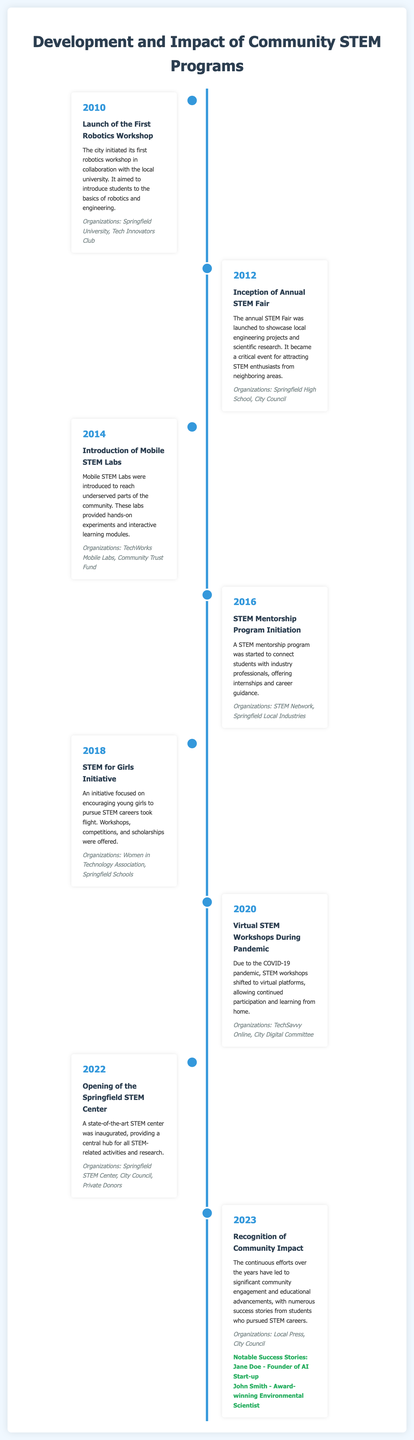what year was the First Robotics Workshop launched? The First Robotics Workshop was launched in 2010, as stated in the timeline.
Answer: 2010 what initiative was introduced in 2014? The initiative introduced in 2014 was Mobile STEM Labs, which aimed to reach underserved parts of the community.
Answer: Mobile STEM Labs which organizations were involved in the STEM for Girls Initiative? The organizations involved in the STEM for Girls Initiative include Women in Technology Association and Springfield Schools, as mentioned in the document.
Answer: Women in Technology Association, Springfield Schools how many years was it from the launch of the first workshop to the opening of the STEM Center? The launch of the first workshop was in 2010 and the STEM Center opened in 2022, which is a span of 12 years.
Answer: 12 years what notable success story is mentioned for the year 2023? The notable success story mentioned in 2023 is Jane Doe, who founded an AI start-up.
Answer: Jane Doe what type of program started in 2016 to connect students with industry professionals? The program that started in 2016 to connect students with industry professionals is the STEM Mentorship Program.
Answer: STEM Mentorship Program what was the main focus of the Annual STEM Fair launched in 2012? The main focus of the Annual STEM Fair was to showcase local engineering projects and scientific research.
Answer: Showcase local engineering projects and scientific research how did the format of STEM workshops change in 2020? In 2020, the format of STEM workshops changed to virtual platforms due to the COVID-19 pandemic.
Answer: Virtual platforms 